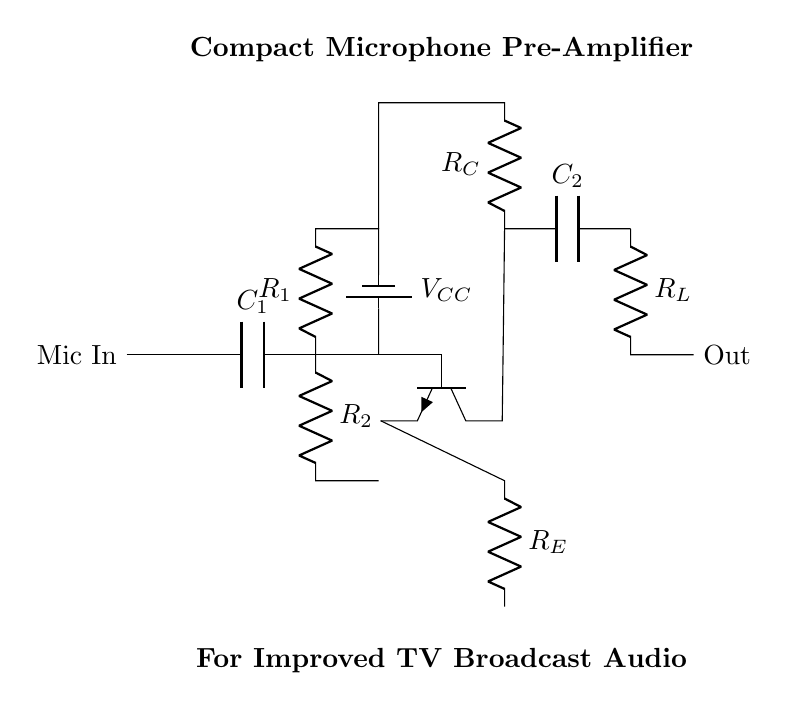What is the type of the transistor used in the circuit? The circuit diagram shows a bipolar junction transistor (BJT) indicated by the npn symbol. The 'npn' designation signifies that the structure of the transistor consists of two n-type semiconductors and one p-type semiconductor.
Answer: npn What is the function of capacitor C1 in the circuit? Capacitor C1 is a coupling capacitor that allows AC signals from the microphone to be passed while blocking any DC voltage. This is important for ensuring that only the audio signal is amplified without any DC offset.
Answer: Coupling What is the purpose of resistor R_E? Resistor R_E serves as an emitter resistor, which helps stabilize the transistor's operating point and improves linearity by providing negative feedback. This plays a crucial role in maintaining consistent performance despite variations in temperature or transistor characteristics.
Answer: Emitter stabilization How many operating voltage sources does the circuit have? The circuit includes a single operating voltage source labeled V_CC, which is used to power the amplifier. This voltage source is crucial for providing the necessary power for the circuit to function.
Answer: One What is the output stage component in the circuit? The output stage uses resistor R_L, which serves the purpose of load resistance in the output circuit, determining how much voltage can be delivered to the subsequent stage or load.
Answer: Load resistor What type of circuit is this? This circuit is a pre-amplifier designed specifically to amplify audio signals coming from a microphone before they are sent to further processing or broadcasting equipment.
Answer: Pre-amplifier What is the significance of capacitor C2 in this circuit? Capacitor C2 acts as a coupling capacitor in the output stage, allowing the amplified AC audio signal to pass while blocking any DC component. This ensures that the output signal remains free of DC offset and is suitable for connection to other audio equipment.
Answer: Coupling 